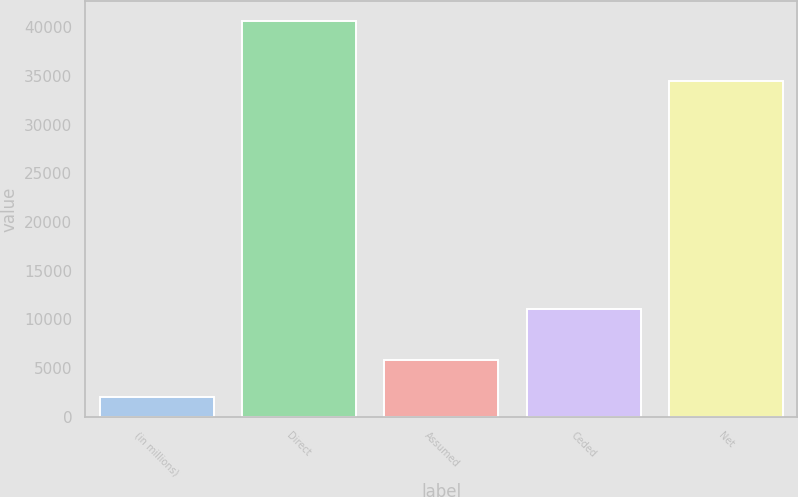Convert chart to OTSL. <chart><loc_0><loc_0><loc_500><loc_500><bar_chart><fcel>(in millions)<fcel>Direct<fcel>Assumed<fcel>Ceded<fcel>Net<nl><fcel>2012<fcel>40647<fcel>5875.5<fcel>11054<fcel>34493<nl></chart> 